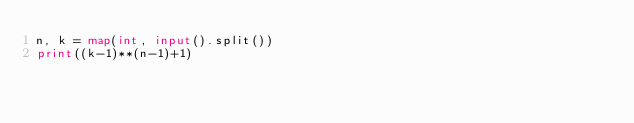<code> <loc_0><loc_0><loc_500><loc_500><_Python_>n, k = map(int, input().split())
print((k-1)**(n-1)+1)</code> 